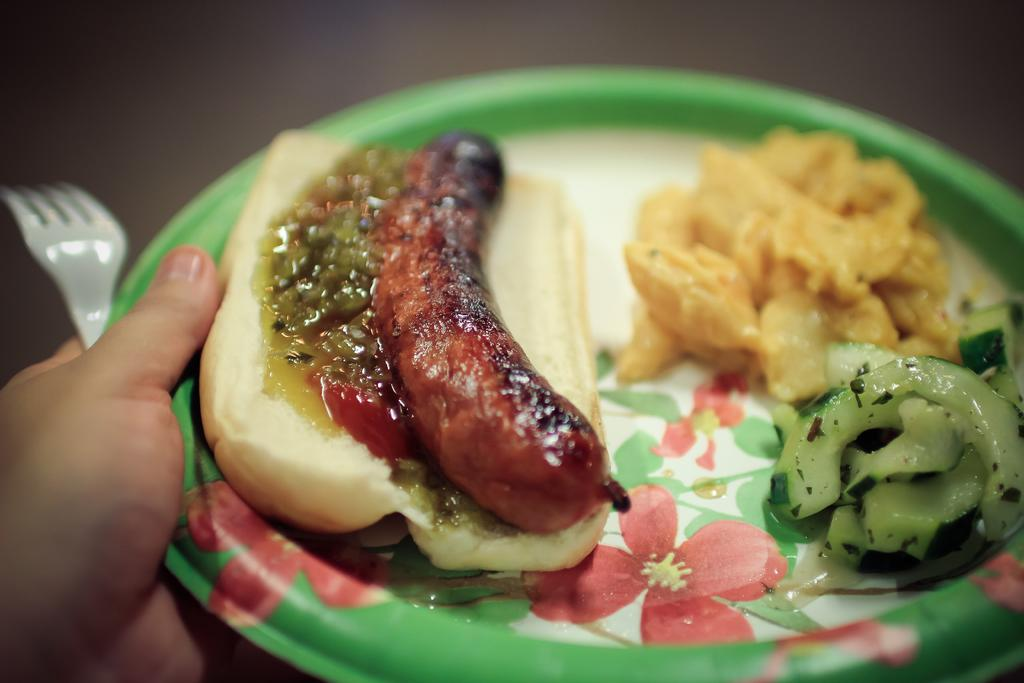What is on the plate that is visible in the image? There is a food item on the plate in the image. What utensil is present in the image? A fork is present in the image. Who or what is holding the fork and plate? A hand is holding the fork and plate in the image. What letters can be seen on the plate in the image? There are no letters visible on the plate in the image. Is there a hose connected to the food item on the plate? There is no hose present in the image, and the food item is not connected to any hose. 